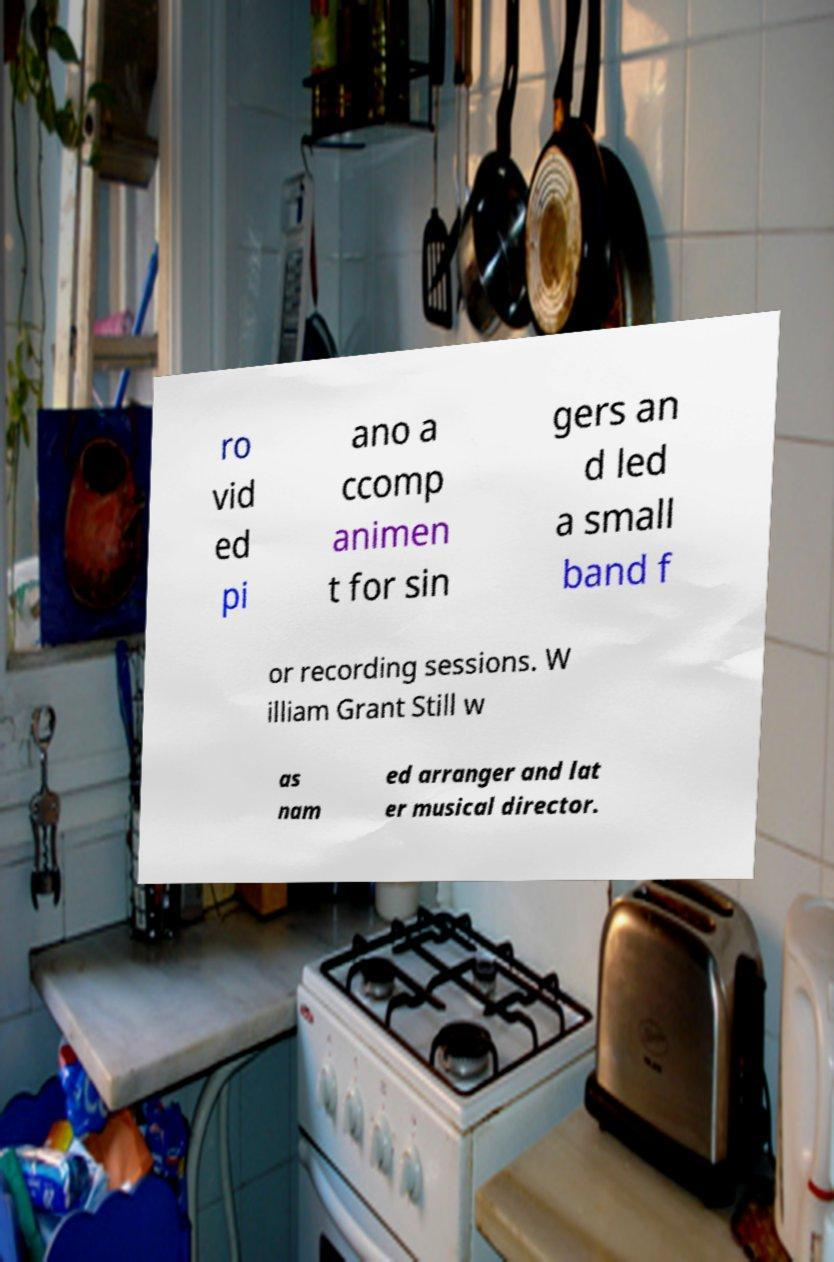What messages or text are displayed in this image? I need them in a readable, typed format. ro vid ed pi ano a ccomp animen t for sin gers an d led a small band f or recording sessions. W illiam Grant Still w as nam ed arranger and lat er musical director. 